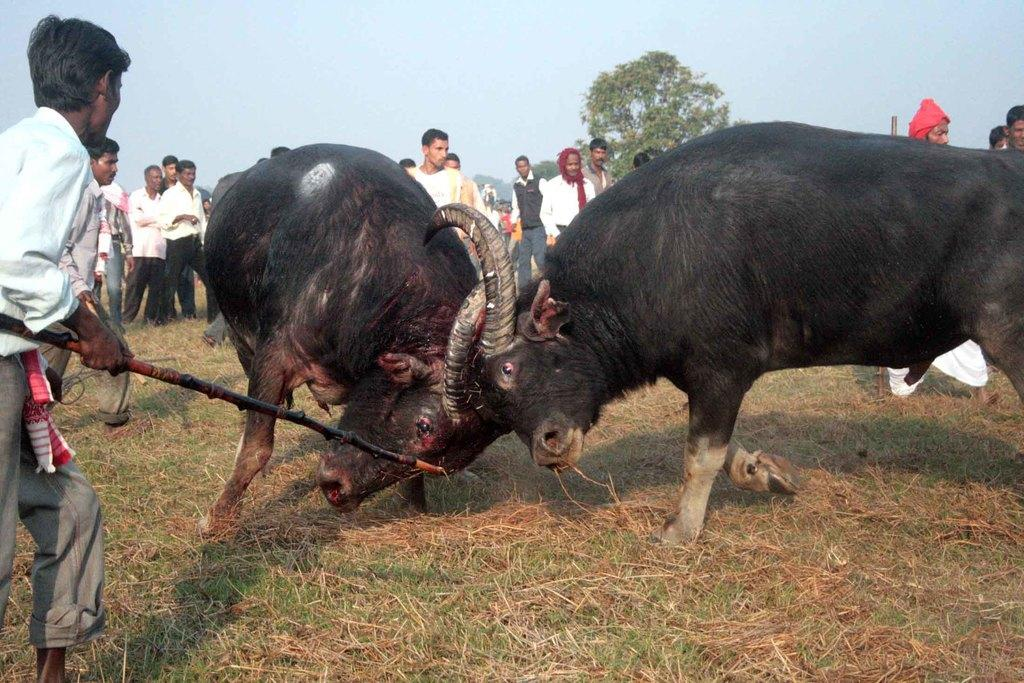What is happening between the two animals in the image? There are two bulls fighting in the image. What is the person in the image doing? The person is standing and holding a stick in the image. What can be seen in the background of the image? There is a group of people and trees in the background of the image. What is visible in the sky in the image? The sky is visible in the background of the image. What type of ink can be seen dripping from the knee of the person in the image? There is no ink or dripping visible in the image, and the person's knee is not mentioned in the provided facts. 